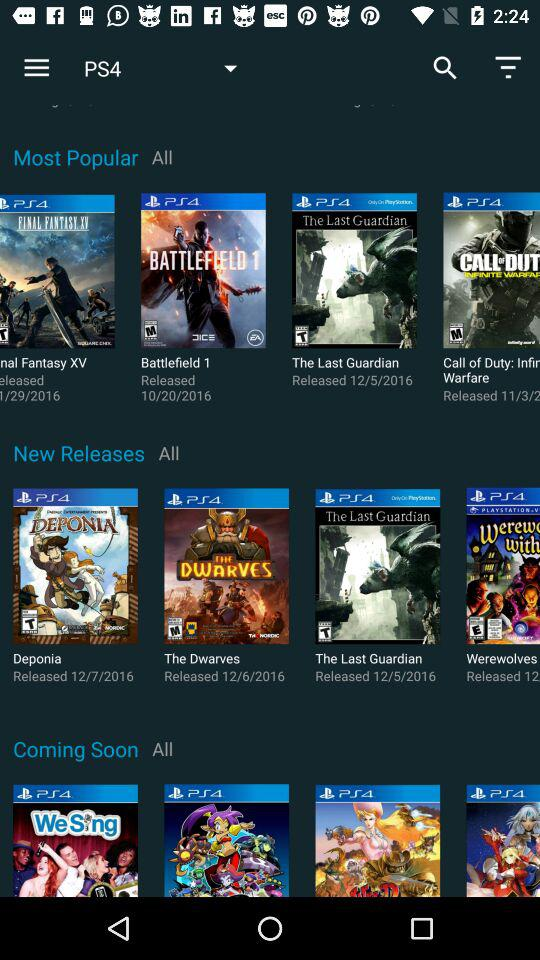What is the release date of "Battlefield 1"? The release date is October 20, 2016. 